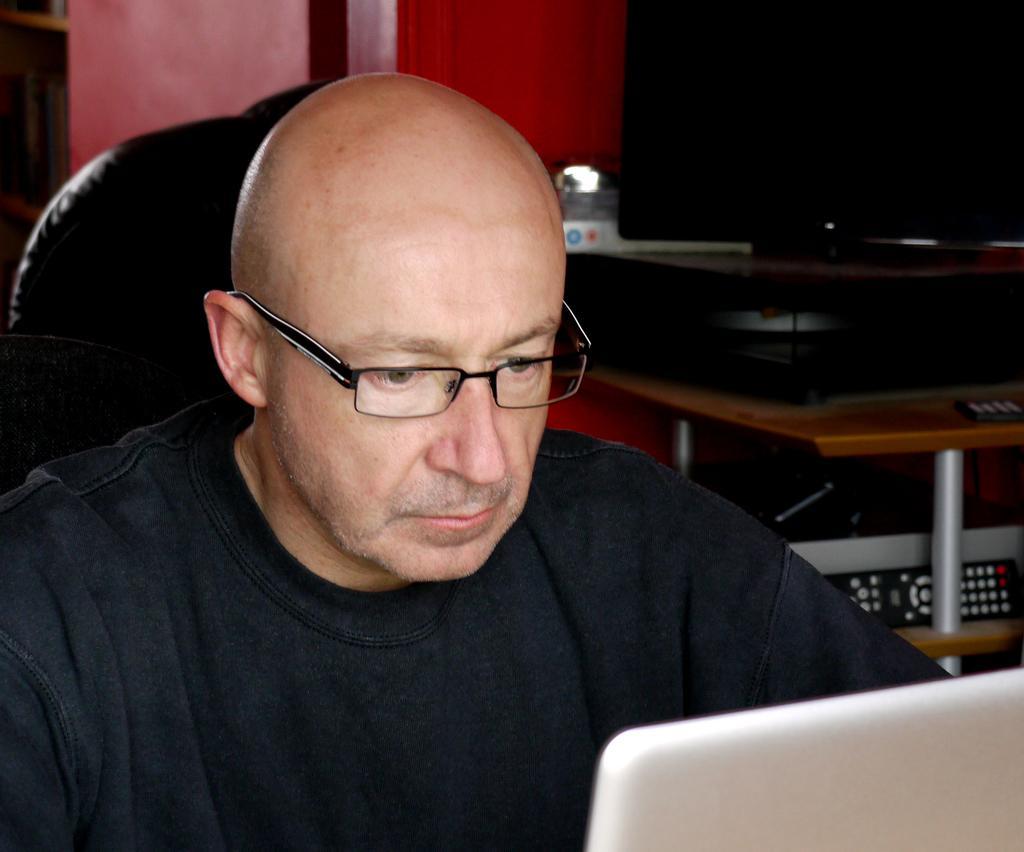Could you give a brief overview of what you see in this image? In this image I can see a person wearing black dress. Back I can see a television,remote and few object on the rack. In front I can see a laptop. 